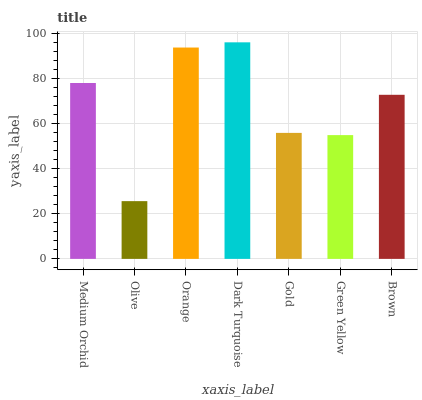Is Olive the minimum?
Answer yes or no. Yes. Is Dark Turquoise the maximum?
Answer yes or no. Yes. Is Orange the minimum?
Answer yes or no. No. Is Orange the maximum?
Answer yes or no. No. Is Orange greater than Olive?
Answer yes or no. Yes. Is Olive less than Orange?
Answer yes or no. Yes. Is Olive greater than Orange?
Answer yes or no. No. Is Orange less than Olive?
Answer yes or no. No. Is Brown the high median?
Answer yes or no. Yes. Is Brown the low median?
Answer yes or no. Yes. Is Dark Turquoise the high median?
Answer yes or no. No. Is Green Yellow the low median?
Answer yes or no. No. 